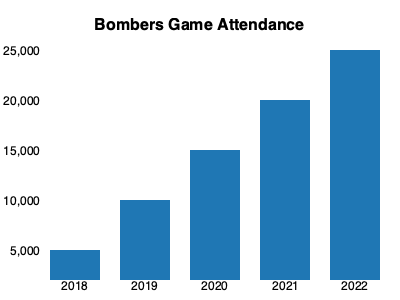Based on the bar chart showing Bombers game attendance from 2018 to 2022, what was the average attendance over these five seasons? To calculate the average attendance, we need to follow these steps:

1. Identify the attendance for each year:
   2018: 5,000
   2019: 10,000
   2020: 15,000
   2021: 20,000
   2022: 25,000

2. Sum up the attendance figures:
   $5,000 + 10,000 + 15,000 + 20,000 + 25,000 = 75,000$

3. Divide the sum by the number of years (5) to get the average:
   $\frac{75,000}{5} = 15,000$

Therefore, the average attendance over these five seasons was 15,000 fans per game.
Answer: 15,000 fans 